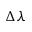<formula> <loc_0><loc_0><loc_500><loc_500>\Delta \lambda</formula> 